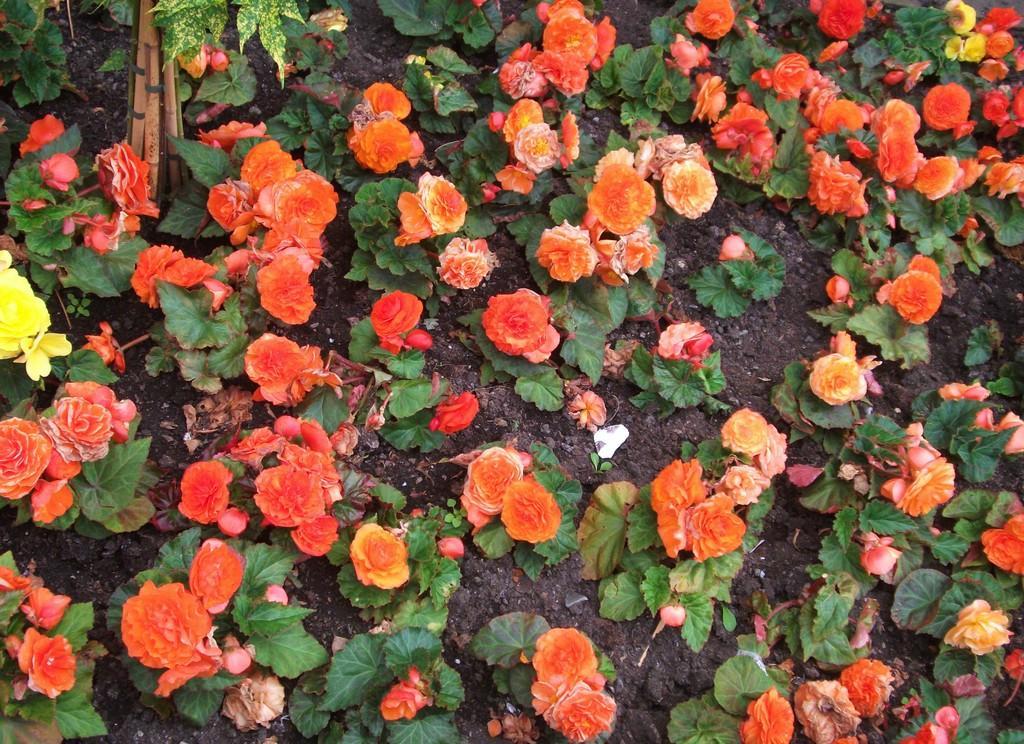How would you summarize this image in a sentence or two? On the left side, there are orange color flowers having green color leaves. On the left side, there is a yellow color flower of a plant. On the top right, there are three yellow color flowers of a plant. In the background, there are stones on the ground. 